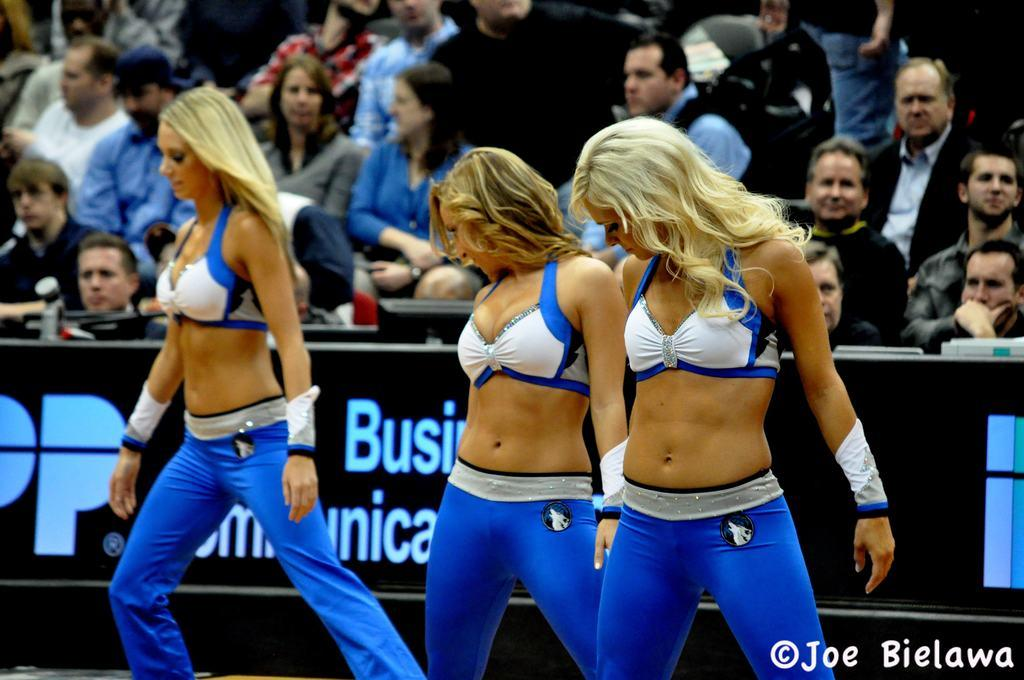<image>
Render a clear and concise summary of the photo. a photograph of sexy dancers by joe bielawa 